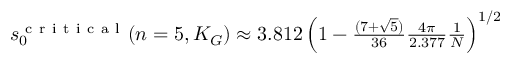Convert formula to latex. <formula><loc_0><loc_0><loc_500><loc_500>\begin{array} { r } { s _ { 0 } ^ { c r i t i c a l } ( n = 5 , K _ { G } ) \approx 3 . 8 1 2 \left ( 1 - \frac { ( 7 + \sqrt { 5 } ) } { 3 6 } \frac { 4 \pi } { 2 . 3 7 7 } \frac { 1 } { N } \right ) ^ { 1 / 2 } } \end{array}</formula> 